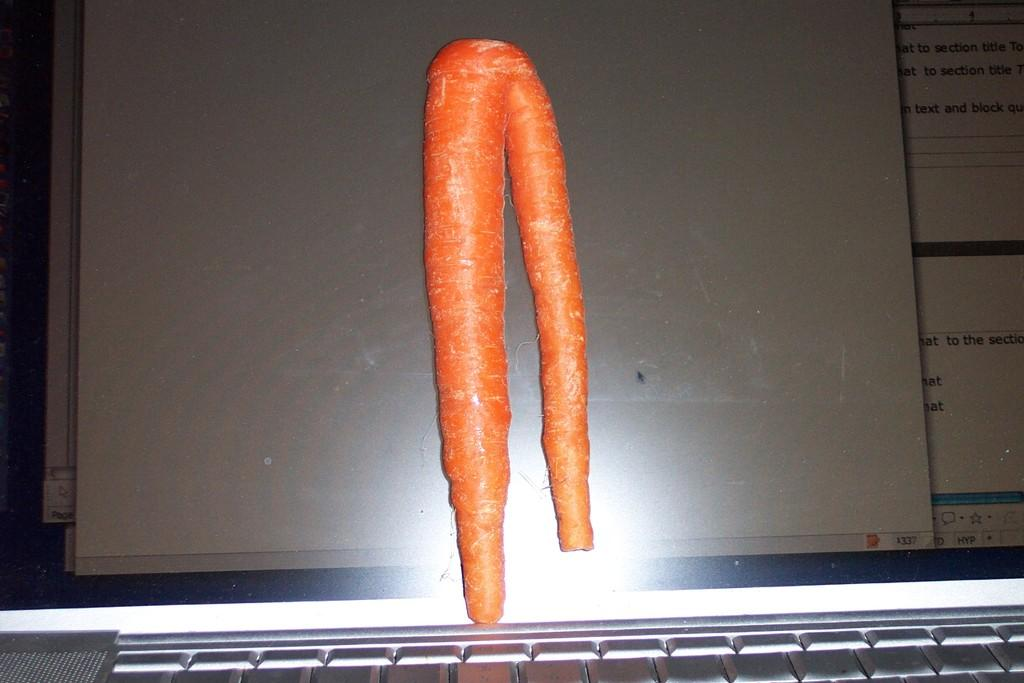What electronic device is present in the image? There is a laptop in the image. What is displayed on the laptop screen? There is a carrot visible on the laptop screen. How does the laptop interact with the friend in the image? There is no friend present in the image, so the laptop cannot interact with a friend. 